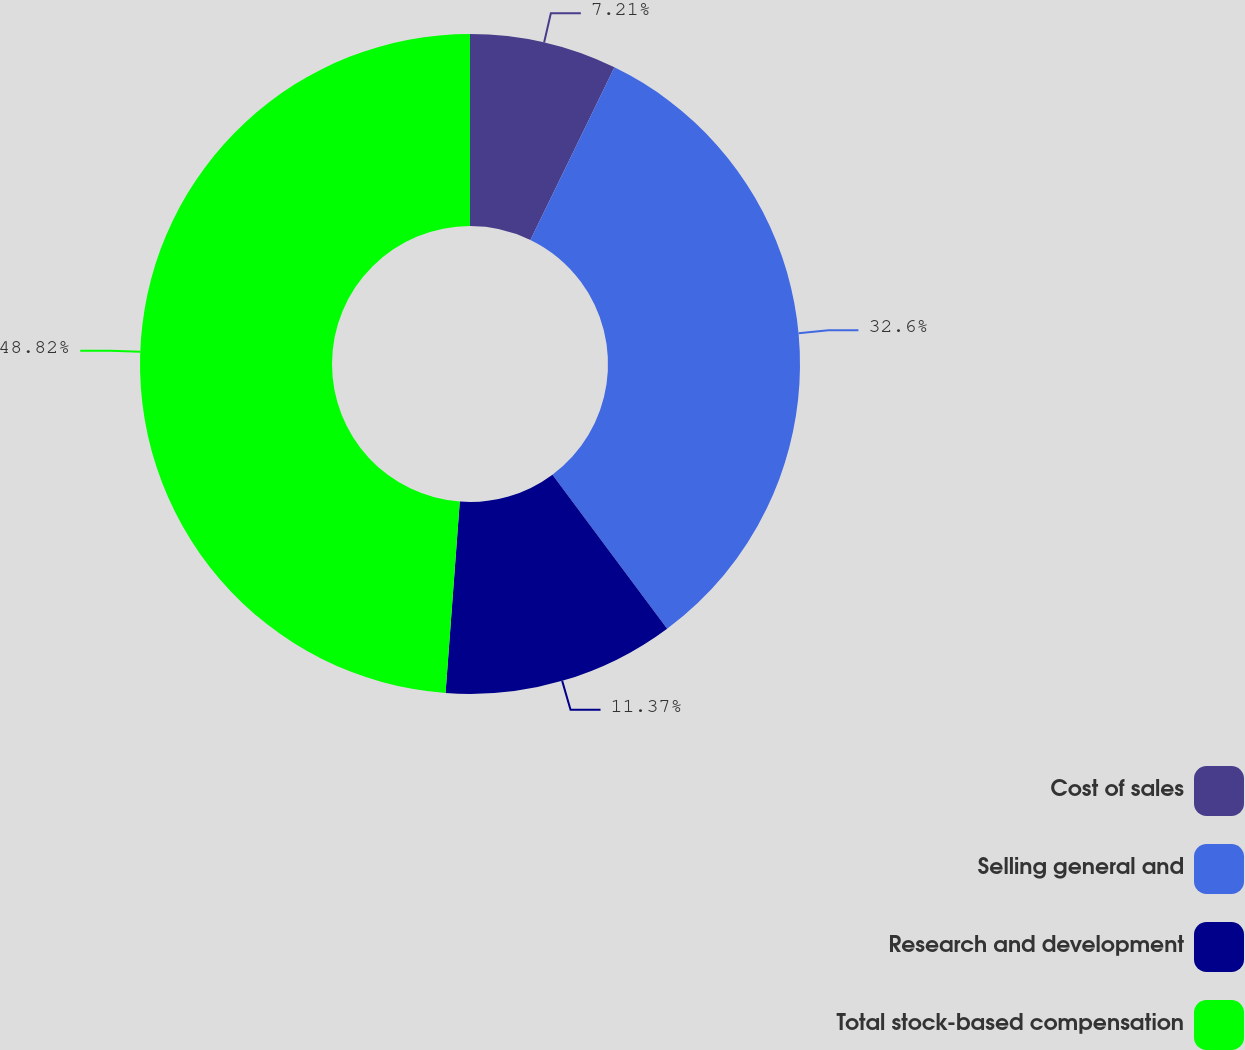Convert chart to OTSL. <chart><loc_0><loc_0><loc_500><loc_500><pie_chart><fcel>Cost of sales<fcel>Selling general and<fcel>Research and development<fcel>Total stock-based compensation<nl><fcel>7.21%<fcel>32.6%<fcel>11.37%<fcel>48.82%<nl></chart> 